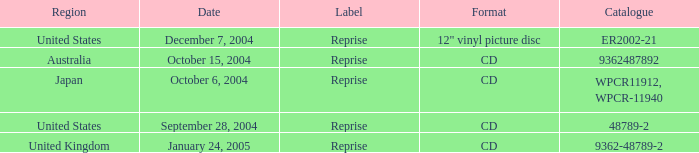I'm looking to parse the entire table for insights. Could you assist me with that? {'header': ['Region', 'Date', 'Label', 'Format', 'Catalogue'], 'rows': [['United States', 'December 7, 2004', 'Reprise', '12" vinyl picture disc', 'ER2002-21'], ['Australia', 'October 15, 2004', 'Reprise', 'CD', '9362487892'], ['Japan', 'October 6, 2004', 'Reprise', 'CD', 'WPCR11912, WPCR-11940'], ['United States', 'September 28, 2004', 'Reprise', 'CD', '48789-2'], ['United Kingdom', 'January 24, 2005', 'Reprise', 'CD', '9362-48789-2']]} Name the date that is a cd September 28, 2004, October 6, 2004, October 15, 2004, January 24, 2005. 